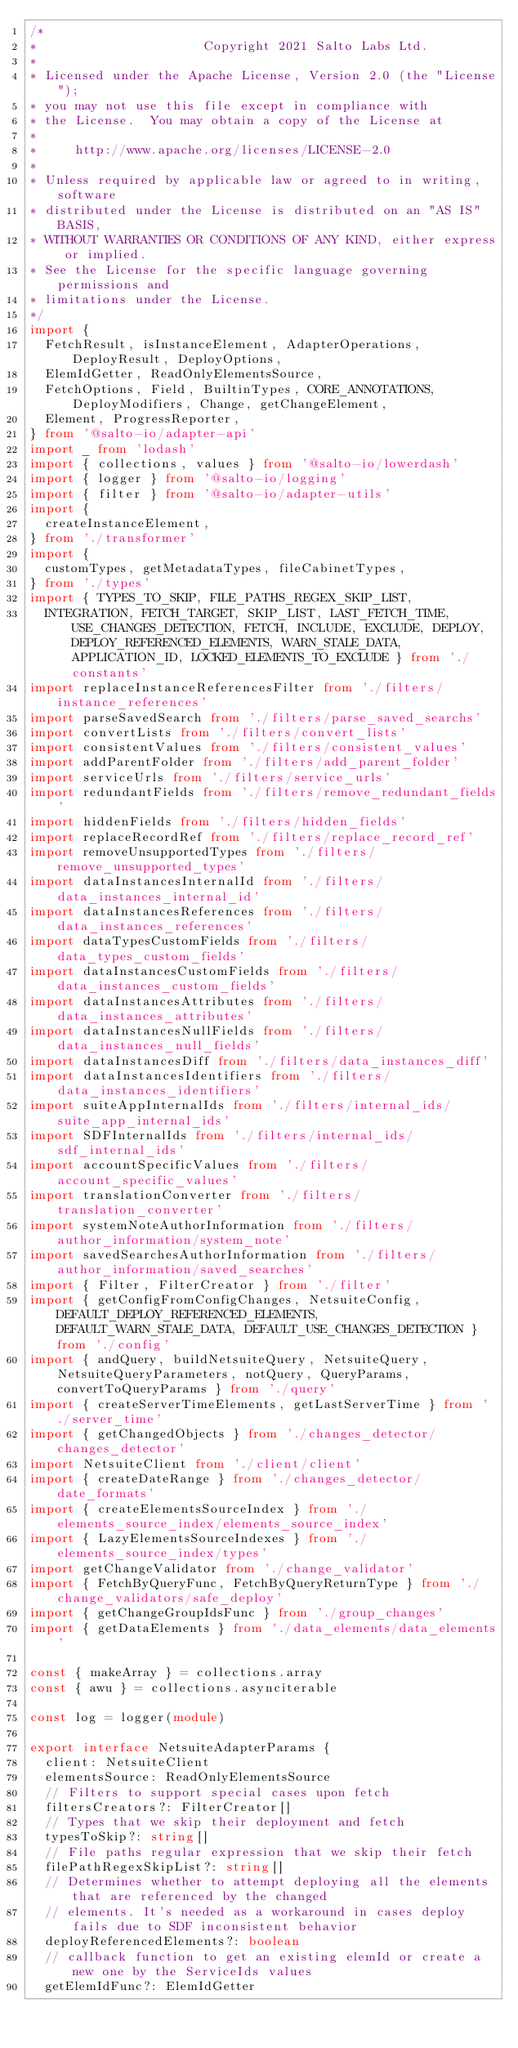Convert code to text. <code><loc_0><loc_0><loc_500><loc_500><_TypeScript_>/*
*                      Copyright 2021 Salto Labs Ltd.
*
* Licensed under the Apache License, Version 2.0 (the "License");
* you may not use this file except in compliance with
* the License.  You may obtain a copy of the License at
*
*     http://www.apache.org/licenses/LICENSE-2.0
*
* Unless required by applicable law or agreed to in writing, software
* distributed under the License is distributed on an "AS IS" BASIS,
* WITHOUT WARRANTIES OR CONDITIONS OF ANY KIND, either express or implied.
* See the License for the specific language governing permissions and
* limitations under the License.
*/
import {
  FetchResult, isInstanceElement, AdapterOperations, DeployResult, DeployOptions,
  ElemIdGetter, ReadOnlyElementsSource,
  FetchOptions, Field, BuiltinTypes, CORE_ANNOTATIONS, DeployModifiers, Change, getChangeElement,
  Element, ProgressReporter,
} from '@salto-io/adapter-api'
import _ from 'lodash'
import { collections, values } from '@salto-io/lowerdash'
import { logger } from '@salto-io/logging'
import { filter } from '@salto-io/adapter-utils'
import {
  createInstanceElement,
} from './transformer'
import {
  customTypes, getMetadataTypes, fileCabinetTypes,
} from './types'
import { TYPES_TO_SKIP, FILE_PATHS_REGEX_SKIP_LIST,
  INTEGRATION, FETCH_TARGET, SKIP_LIST, LAST_FETCH_TIME, USE_CHANGES_DETECTION, FETCH, INCLUDE, EXCLUDE, DEPLOY, DEPLOY_REFERENCED_ELEMENTS, WARN_STALE_DATA, APPLICATION_ID, LOCKED_ELEMENTS_TO_EXCLUDE } from './constants'
import replaceInstanceReferencesFilter from './filters/instance_references'
import parseSavedSearch from './filters/parse_saved_searchs'
import convertLists from './filters/convert_lists'
import consistentValues from './filters/consistent_values'
import addParentFolder from './filters/add_parent_folder'
import serviceUrls from './filters/service_urls'
import redundantFields from './filters/remove_redundant_fields'
import hiddenFields from './filters/hidden_fields'
import replaceRecordRef from './filters/replace_record_ref'
import removeUnsupportedTypes from './filters/remove_unsupported_types'
import dataInstancesInternalId from './filters/data_instances_internal_id'
import dataInstancesReferences from './filters/data_instances_references'
import dataTypesCustomFields from './filters/data_types_custom_fields'
import dataInstancesCustomFields from './filters/data_instances_custom_fields'
import dataInstancesAttributes from './filters/data_instances_attributes'
import dataInstancesNullFields from './filters/data_instances_null_fields'
import dataInstancesDiff from './filters/data_instances_diff'
import dataInstancesIdentifiers from './filters/data_instances_identifiers'
import suiteAppInternalIds from './filters/internal_ids/suite_app_internal_ids'
import SDFInternalIds from './filters/internal_ids/sdf_internal_ids'
import accountSpecificValues from './filters/account_specific_values'
import translationConverter from './filters/translation_converter'
import systemNoteAuthorInformation from './filters/author_information/system_note'
import savedSearchesAuthorInformation from './filters/author_information/saved_searches'
import { Filter, FilterCreator } from './filter'
import { getConfigFromConfigChanges, NetsuiteConfig, DEFAULT_DEPLOY_REFERENCED_ELEMENTS, DEFAULT_WARN_STALE_DATA, DEFAULT_USE_CHANGES_DETECTION } from './config'
import { andQuery, buildNetsuiteQuery, NetsuiteQuery, NetsuiteQueryParameters, notQuery, QueryParams, convertToQueryParams } from './query'
import { createServerTimeElements, getLastServerTime } from './server_time'
import { getChangedObjects } from './changes_detector/changes_detector'
import NetsuiteClient from './client/client'
import { createDateRange } from './changes_detector/date_formats'
import { createElementsSourceIndex } from './elements_source_index/elements_source_index'
import { LazyElementsSourceIndexes } from './elements_source_index/types'
import getChangeValidator from './change_validator'
import { FetchByQueryFunc, FetchByQueryReturnType } from './change_validators/safe_deploy'
import { getChangeGroupIdsFunc } from './group_changes'
import { getDataElements } from './data_elements/data_elements'

const { makeArray } = collections.array
const { awu } = collections.asynciterable

const log = logger(module)

export interface NetsuiteAdapterParams {
  client: NetsuiteClient
  elementsSource: ReadOnlyElementsSource
  // Filters to support special cases upon fetch
  filtersCreators?: FilterCreator[]
  // Types that we skip their deployment and fetch
  typesToSkip?: string[]
  // File paths regular expression that we skip their fetch
  filePathRegexSkipList?: string[]
  // Determines whether to attempt deploying all the elements that are referenced by the changed
  // elements. It's needed as a workaround in cases deploy fails due to SDF inconsistent behavior
  deployReferencedElements?: boolean
  // callback function to get an existing elemId or create a new one by the ServiceIds values
  getElemIdFunc?: ElemIdGetter</code> 